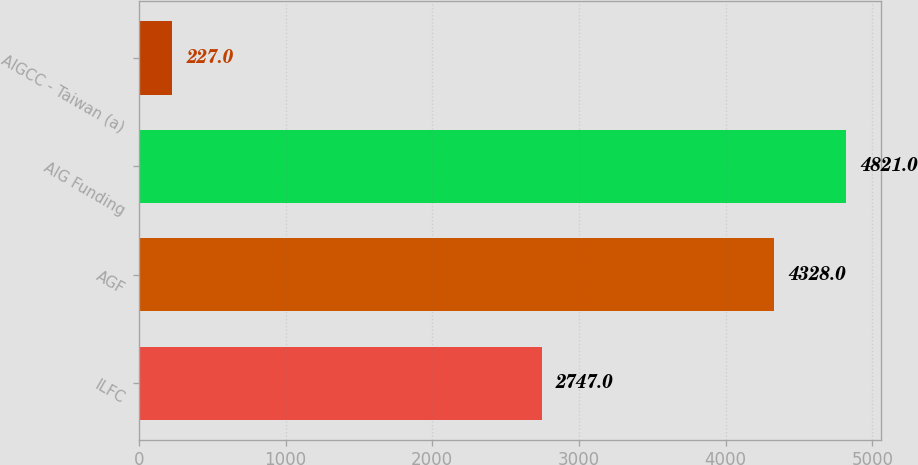<chart> <loc_0><loc_0><loc_500><loc_500><bar_chart><fcel>ILFC<fcel>AGF<fcel>AIG Funding<fcel>AIGCC - Taiwan (a)<nl><fcel>2747<fcel>4328<fcel>4821<fcel>227<nl></chart> 